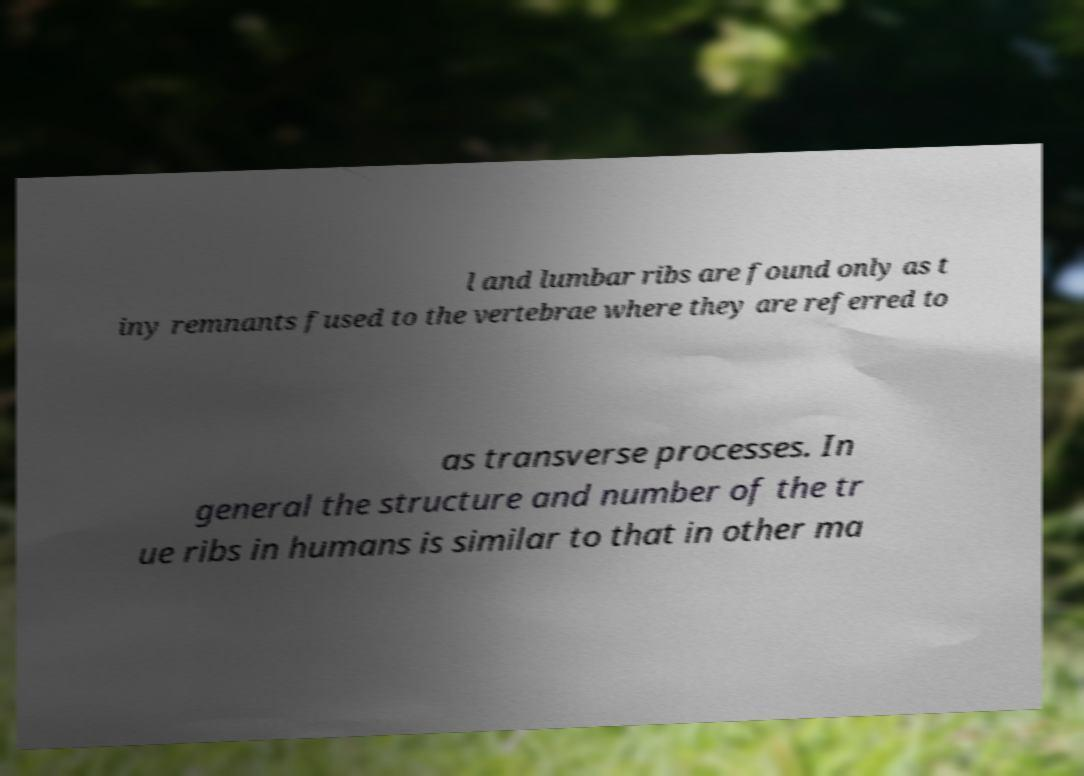There's text embedded in this image that I need extracted. Can you transcribe it verbatim? l and lumbar ribs are found only as t iny remnants fused to the vertebrae where they are referred to as transverse processes. In general the structure and number of the tr ue ribs in humans is similar to that in other ma 